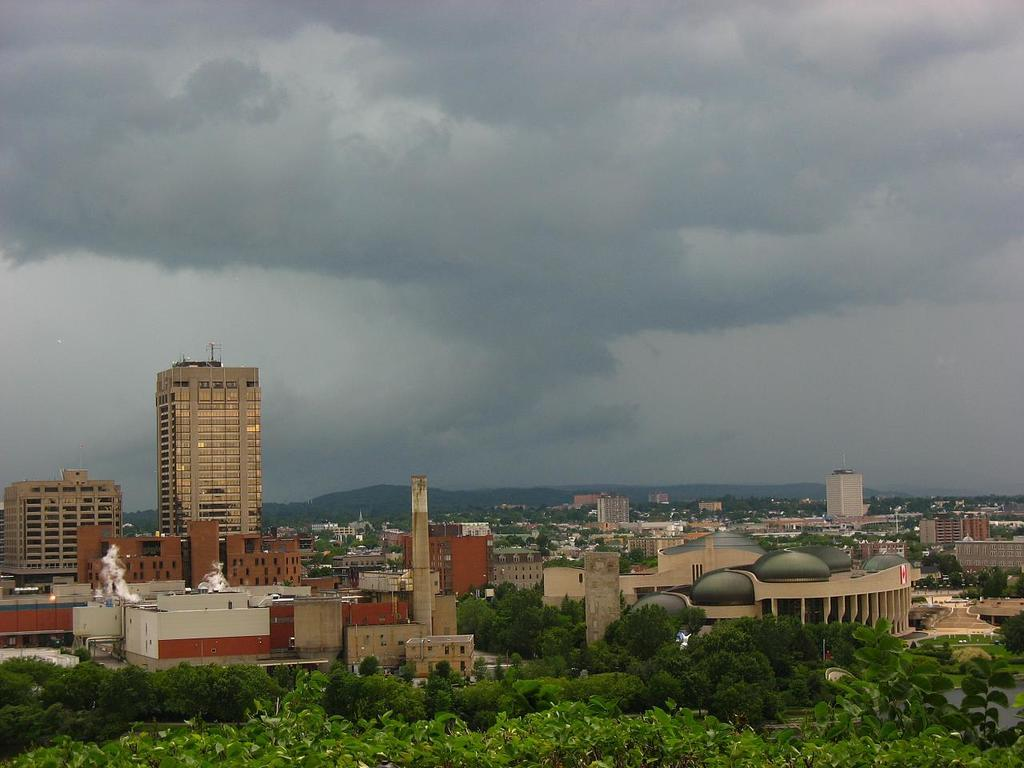What type of view is depicted in the image? The image is an aerial view. What structures can be seen in the image? There are buildings in the image. What natural features are present in the image? There are hills and trees in the image. What part of the buildings is visible in the image? There are roofs visible in the image. What is visible in the sky at the top of the image? Clouds are present in the sky at the top of the image. Can you see a squirrel climbing a tree in the image? There is no squirrel visible in the image; it only features buildings, hills, trees, roofs, and clouds. Is there a doll sitting on top of one of the buildings in the image? There is no doll present in the image; it only features buildings, hills, trees, roofs, and clouds. 